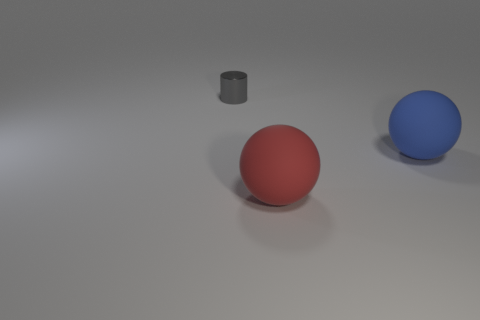Add 2 small gray metal cylinders. How many objects exist? 5 Subtract all cylinders. How many objects are left? 2 Add 1 tiny things. How many tiny things are left? 2 Add 3 large rubber balls. How many large rubber balls exist? 5 Subtract 0 brown balls. How many objects are left? 3 Subtract all big brown shiny objects. Subtract all small shiny cylinders. How many objects are left? 2 